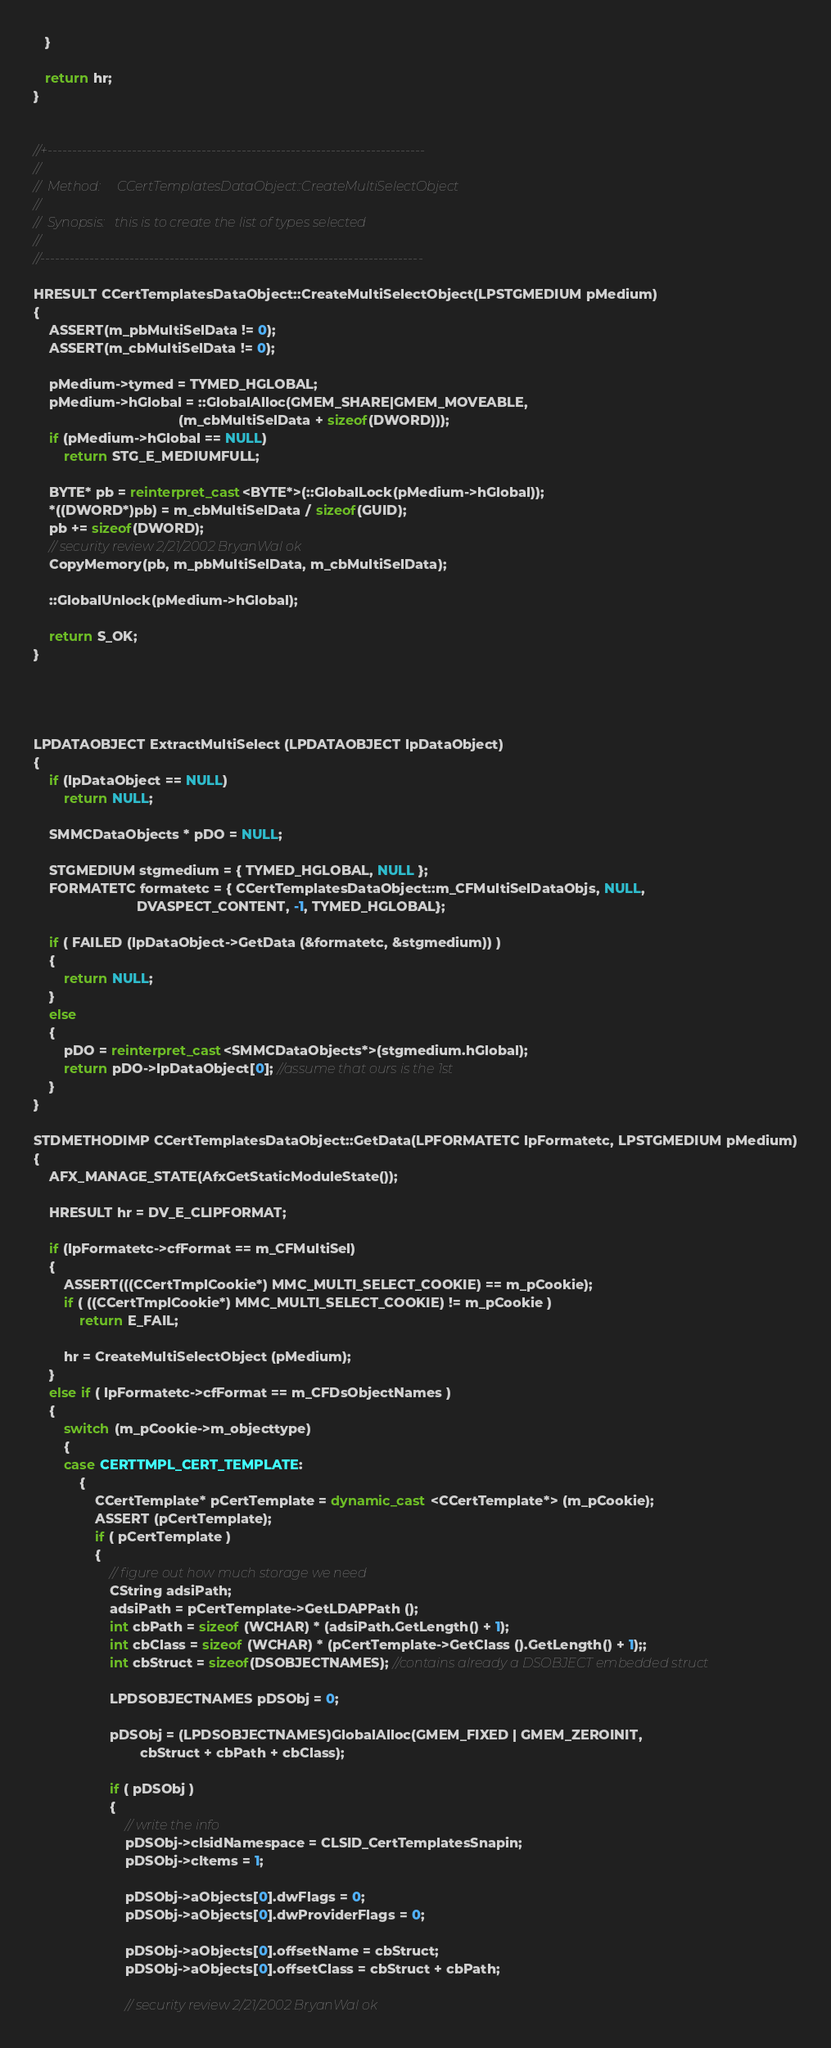<code> <loc_0><loc_0><loc_500><loc_500><_C++_>   }

   return hr;
}


//+----------------------------------------------------------------------------
//
//  Method:     CCertTemplatesDataObject::CreateMultiSelectObject
//
//  Synopsis:   this is to create the list of types selected
//
//-----------------------------------------------------------------------------

HRESULT CCertTemplatesDataObject::CreateMultiSelectObject(LPSTGMEDIUM pMedium)
{
    ASSERT(m_pbMultiSelData != 0);
    ASSERT(m_cbMultiSelData != 0);

    pMedium->tymed = TYMED_HGLOBAL;
    pMedium->hGlobal = ::GlobalAlloc(GMEM_SHARE|GMEM_MOVEABLE,
                                      (m_cbMultiSelData + sizeof(DWORD)));
    if (pMedium->hGlobal == NULL)
        return STG_E_MEDIUMFULL;

    BYTE* pb = reinterpret_cast<BYTE*>(::GlobalLock(pMedium->hGlobal));
    *((DWORD*)pb) = m_cbMultiSelData / sizeof(GUID);
    pb += sizeof(DWORD);
    // security review 2/21/2002 BryanWal ok
    CopyMemory(pb, m_pbMultiSelData, m_cbMultiSelData);

    ::GlobalUnlock(pMedium->hGlobal);

	return S_OK;
}




LPDATAOBJECT ExtractMultiSelect (LPDATAOBJECT lpDataObject)
{
	if (lpDataObject == NULL)
		return NULL;

	SMMCDataObjects * pDO = NULL;

	STGMEDIUM stgmedium = { TYMED_HGLOBAL, NULL };
	FORMATETC formatetc = { CCertTemplatesDataObject::m_CFMultiSelDataObjs, NULL,
                           DVASPECT_CONTENT, -1, TYMED_HGLOBAL};

	if ( FAILED (lpDataObject->GetData (&formatetc, &stgmedium)) )
	{
		return NULL;
	}
	else
	{
		pDO = reinterpret_cast<SMMCDataObjects*>(stgmedium.hGlobal);
		return pDO->lpDataObject[0]; //assume that ours is the 1st
	}
}

STDMETHODIMP CCertTemplatesDataObject::GetData(LPFORMATETC lpFormatetc, LPSTGMEDIUM pMedium)
{
    AFX_MANAGE_STATE(AfxGetStaticModuleState());

    HRESULT hr = DV_E_CLIPFORMAT;

    if (lpFormatetc->cfFormat == m_CFMultiSel)
    {
        ASSERT(((CCertTmplCookie*) MMC_MULTI_SELECT_COOKIE) == m_pCookie);
        if ( ((CCertTmplCookie*) MMC_MULTI_SELECT_COOKIE) != m_pCookie )
            return E_FAIL;

        hr = CreateMultiSelectObject (pMedium);
    }
	else if ( lpFormatetc->cfFormat == m_CFDsObjectNames )
	{
		switch (m_pCookie->m_objecttype)
		{
        case CERTTMPL_CERT_TEMPLATE:
			{
				CCertTemplate* pCertTemplate = dynamic_cast <CCertTemplate*> (m_pCookie);
				ASSERT (pCertTemplate);
				if ( pCertTemplate )
				{
					// figure out how much storage we need
                    CString adsiPath;
                    adsiPath = pCertTemplate->GetLDAPPath ();
					int cbPath = sizeof (WCHAR) * (adsiPath.GetLength() + 1);
					int cbClass = sizeof (WCHAR) * (pCertTemplate->GetClass ().GetLength() + 1);;
					int cbStruct = sizeof(DSOBJECTNAMES); //contains already a DSOBJECT embedded struct

					LPDSOBJECTNAMES pDSObj = 0;

					pDSObj = (LPDSOBJECTNAMES)GlobalAlloc(GMEM_FIXED | GMEM_ZEROINIT,
							cbStruct + cbPath + cbClass);

					if ( pDSObj )
					{
						// write the info
						pDSObj->clsidNamespace = CLSID_CertTemplatesSnapin;
						pDSObj->cItems = 1;

						pDSObj->aObjects[0].dwFlags = 0;
						pDSObj->aObjects[0].dwProviderFlags = 0;

						pDSObj->aObjects[0].offsetName = cbStruct;
						pDSObj->aObjects[0].offsetClass = cbStruct + cbPath;

                        // security review 2/21/2002 BryanWal ok</code> 